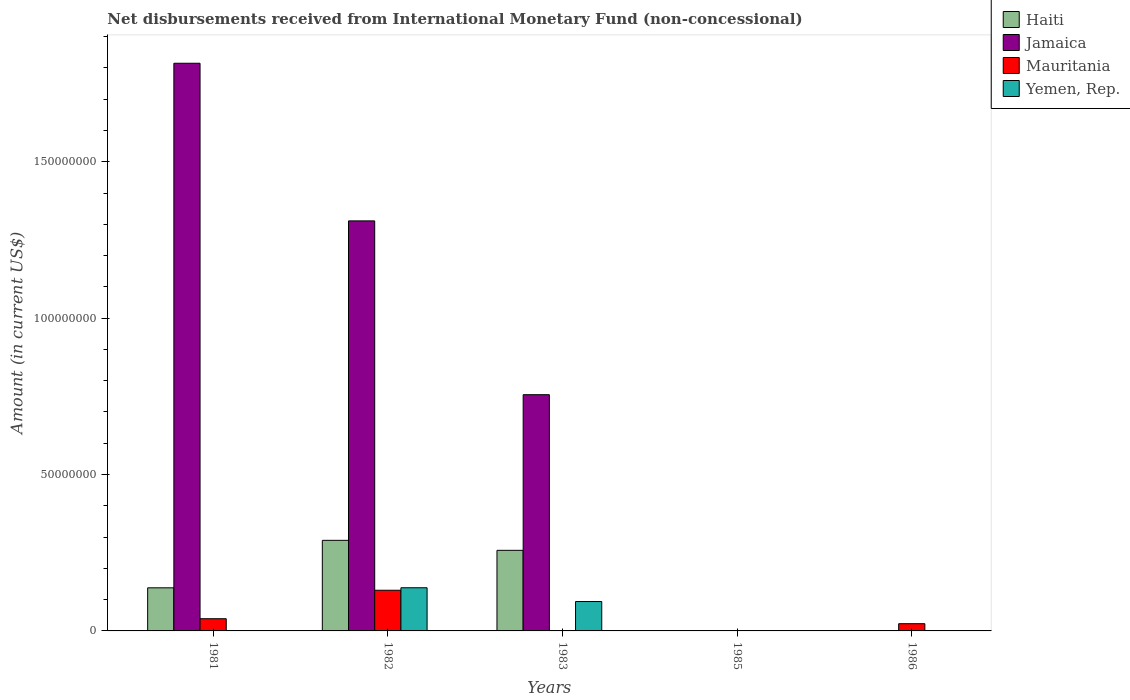How many different coloured bars are there?
Provide a succinct answer. 4. Are the number of bars per tick equal to the number of legend labels?
Offer a terse response. No. What is the label of the 4th group of bars from the left?
Your answer should be compact. 1985. In how many cases, is the number of bars for a given year not equal to the number of legend labels?
Your answer should be very brief. 4. Across all years, what is the maximum amount of disbursements received from International Monetary Fund in Yemen, Rep.?
Make the answer very short. 1.38e+07. Across all years, what is the minimum amount of disbursements received from International Monetary Fund in Jamaica?
Keep it short and to the point. 0. What is the total amount of disbursements received from International Monetary Fund in Jamaica in the graph?
Your answer should be compact. 3.88e+08. What is the difference between the amount of disbursements received from International Monetary Fund in Mauritania in 1982 and that in 1986?
Make the answer very short. 1.07e+07. What is the difference between the amount of disbursements received from International Monetary Fund in Jamaica in 1981 and the amount of disbursements received from International Monetary Fund in Mauritania in 1986?
Provide a short and direct response. 1.79e+08. What is the average amount of disbursements received from International Monetary Fund in Mauritania per year?
Your response must be concise. 3.84e+06. In the year 1981, what is the difference between the amount of disbursements received from International Monetary Fund in Jamaica and amount of disbursements received from International Monetary Fund in Haiti?
Your answer should be very brief. 1.68e+08. In how many years, is the amount of disbursements received from International Monetary Fund in Mauritania greater than 100000000 US$?
Offer a very short reply. 0. What is the ratio of the amount of disbursements received from International Monetary Fund in Haiti in 1981 to that in 1982?
Provide a succinct answer. 0.48. What is the difference between the highest and the second highest amount of disbursements received from International Monetary Fund in Mauritania?
Keep it short and to the point. 9.10e+06. What is the difference between the highest and the lowest amount of disbursements received from International Monetary Fund in Jamaica?
Your response must be concise. 1.82e+08. In how many years, is the amount of disbursements received from International Monetary Fund in Mauritania greater than the average amount of disbursements received from International Monetary Fund in Mauritania taken over all years?
Give a very brief answer. 2. Is the sum of the amount of disbursements received from International Monetary Fund in Mauritania in 1982 and 1986 greater than the maximum amount of disbursements received from International Monetary Fund in Jamaica across all years?
Your response must be concise. No. Is it the case that in every year, the sum of the amount of disbursements received from International Monetary Fund in Jamaica and amount of disbursements received from International Monetary Fund in Mauritania is greater than the sum of amount of disbursements received from International Monetary Fund in Haiti and amount of disbursements received from International Monetary Fund in Yemen, Rep.?
Offer a very short reply. No. What is the difference between two consecutive major ticks on the Y-axis?
Ensure brevity in your answer.  5.00e+07. How are the legend labels stacked?
Keep it short and to the point. Vertical. What is the title of the graph?
Keep it short and to the point. Net disbursements received from International Monetary Fund (non-concessional). What is the label or title of the X-axis?
Offer a very short reply. Years. What is the Amount (in current US$) in Haiti in 1981?
Provide a short and direct response. 1.38e+07. What is the Amount (in current US$) in Jamaica in 1981?
Provide a succinct answer. 1.82e+08. What is the Amount (in current US$) of Mauritania in 1981?
Your response must be concise. 3.90e+06. What is the Amount (in current US$) of Haiti in 1982?
Offer a very short reply. 2.90e+07. What is the Amount (in current US$) in Jamaica in 1982?
Your response must be concise. 1.31e+08. What is the Amount (in current US$) of Mauritania in 1982?
Your response must be concise. 1.30e+07. What is the Amount (in current US$) of Yemen, Rep. in 1982?
Offer a terse response. 1.38e+07. What is the Amount (in current US$) in Haiti in 1983?
Offer a terse response. 2.58e+07. What is the Amount (in current US$) of Jamaica in 1983?
Make the answer very short. 7.55e+07. What is the Amount (in current US$) in Yemen, Rep. in 1983?
Provide a short and direct response. 9.40e+06. What is the Amount (in current US$) in Jamaica in 1985?
Give a very brief answer. 0. What is the Amount (in current US$) of Mauritania in 1985?
Ensure brevity in your answer.  0. What is the Amount (in current US$) in Yemen, Rep. in 1985?
Keep it short and to the point. 0. What is the Amount (in current US$) of Mauritania in 1986?
Ensure brevity in your answer.  2.31e+06. What is the Amount (in current US$) in Yemen, Rep. in 1986?
Your answer should be compact. 0. Across all years, what is the maximum Amount (in current US$) of Haiti?
Ensure brevity in your answer.  2.90e+07. Across all years, what is the maximum Amount (in current US$) in Jamaica?
Your answer should be very brief. 1.82e+08. Across all years, what is the maximum Amount (in current US$) of Mauritania?
Offer a very short reply. 1.30e+07. Across all years, what is the maximum Amount (in current US$) in Yemen, Rep.?
Your answer should be very brief. 1.38e+07. Across all years, what is the minimum Amount (in current US$) in Yemen, Rep.?
Make the answer very short. 0. What is the total Amount (in current US$) in Haiti in the graph?
Give a very brief answer. 6.85e+07. What is the total Amount (in current US$) of Jamaica in the graph?
Make the answer very short. 3.88e+08. What is the total Amount (in current US$) of Mauritania in the graph?
Keep it short and to the point. 1.92e+07. What is the total Amount (in current US$) of Yemen, Rep. in the graph?
Your answer should be compact. 2.32e+07. What is the difference between the Amount (in current US$) in Haiti in 1981 and that in 1982?
Your response must be concise. -1.52e+07. What is the difference between the Amount (in current US$) in Jamaica in 1981 and that in 1982?
Provide a short and direct response. 5.04e+07. What is the difference between the Amount (in current US$) of Mauritania in 1981 and that in 1982?
Your answer should be very brief. -9.10e+06. What is the difference between the Amount (in current US$) of Haiti in 1981 and that in 1983?
Provide a short and direct response. -1.20e+07. What is the difference between the Amount (in current US$) of Jamaica in 1981 and that in 1983?
Your answer should be compact. 1.06e+08. What is the difference between the Amount (in current US$) in Mauritania in 1981 and that in 1986?
Ensure brevity in your answer.  1.59e+06. What is the difference between the Amount (in current US$) in Haiti in 1982 and that in 1983?
Ensure brevity in your answer.  3.20e+06. What is the difference between the Amount (in current US$) in Jamaica in 1982 and that in 1983?
Your answer should be compact. 5.56e+07. What is the difference between the Amount (in current US$) in Yemen, Rep. in 1982 and that in 1983?
Offer a very short reply. 4.40e+06. What is the difference between the Amount (in current US$) of Mauritania in 1982 and that in 1986?
Give a very brief answer. 1.07e+07. What is the difference between the Amount (in current US$) of Haiti in 1981 and the Amount (in current US$) of Jamaica in 1982?
Your answer should be very brief. -1.17e+08. What is the difference between the Amount (in current US$) of Haiti in 1981 and the Amount (in current US$) of Mauritania in 1982?
Offer a very short reply. 7.81e+05. What is the difference between the Amount (in current US$) in Haiti in 1981 and the Amount (in current US$) in Yemen, Rep. in 1982?
Your answer should be very brief. -1.90e+04. What is the difference between the Amount (in current US$) of Jamaica in 1981 and the Amount (in current US$) of Mauritania in 1982?
Your response must be concise. 1.68e+08. What is the difference between the Amount (in current US$) in Jamaica in 1981 and the Amount (in current US$) in Yemen, Rep. in 1982?
Offer a terse response. 1.68e+08. What is the difference between the Amount (in current US$) in Mauritania in 1981 and the Amount (in current US$) in Yemen, Rep. in 1982?
Give a very brief answer. -9.90e+06. What is the difference between the Amount (in current US$) of Haiti in 1981 and the Amount (in current US$) of Jamaica in 1983?
Your response must be concise. -6.17e+07. What is the difference between the Amount (in current US$) of Haiti in 1981 and the Amount (in current US$) of Yemen, Rep. in 1983?
Your response must be concise. 4.38e+06. What is the difference between the Amount (in current US$) in Jamaica in 1981 and the Amount (in current US$) in Yemen, Rep. in 1983?
Offer a very short reply. 1.72e+08. What is the difference between the Amount (in current US$) of Mauritania in 1981 and the Amount (in current US$) of Yemen, Rep. in 1983?
Offer a terse response. -5.50e+06. What is the difference between the Amount (in current US$) of Haiti in 1981 and the Amount (in current US$) of Mauritania in 1986?
Your response must be concise. 1.15e+07. What is the difference between the Amount (in current US$) of Jamaica in 1981 and the Amount (in current US$) of Mauritania in 1986?
Ensure brevity in your answer.  1.79e+08. What is the difference between the Amount (in current US$) of Haiti in 1982 and the Amount (in current US$) of Jamaica in 1983?
Your answer should be compact. -4.66e+07. What is the difference between the Amount (in current US$) in Haiti in 1982 and the Amount (in current US$) in Yemen, Rep. in 1983?
Give a very brief answer. 1.96e+07. What is the difference between the Amount (in current US$) of Jamaica in 1982 and the Amount (in current US$) of Yemen, Rep. in 1983?
Offer a very short reply. 1.22e+08. What is the difference between the Amount (in current US$) of Mauritania in 1982 and the Amount (in current US$) of Yemen, Rep. in 1983?
Ensure brevity in your answer.  3.60e+06. What is the difference between the Amount (in current US$) of Haiti in 1982 and the Amount (in current US$) of Mauritania in 1986?
Give a very brief answer. 2.67e+07. What is the difference between the Amount (in current US$) in Jamaica in 1982 and the Amount (in current US$) in Mauritania in 1986?
Provide a short and direct response. 1.29e+08. What is the difference between the Amount (in current US$) of Haiti in 1983 and the Amount (in current US$) of Mauritania in 1986?
Keep it short and to the point. 2.35e+07. What is the difference between the Amount (in current US$) in Jamaica in 1983 and the Amount (in current US$) in Mauritania in 1986?
Offer a terse response. 7.32e+07. What is the average Amount (in current US$) of Haiti per year?
Offer a terse response. 1.37e+07. What is the average Amount (in current US$) in Jamaica per year?
Ensure brevity in your answer.  7.76e+07. What is the average Amount (in current US$) of Mauritania per year?
Ensure brevity in your answer.  3.84e+06. What is the average Amount (in current US$) in Yemen, Rep. per year?
Give a very brief answer. 4.64e+06. In the year 1981, what is the difference between the Amount (in current US$) of Haiti and Amount (in current US$) of Jamaica?
Your response must be concise. -1.68e+08. In the year 1981, what is the difference between the Amount (in current US$) in Haiti and Amount (in current US$) in Mauritania?
Ensure brevity in your answer.  9.88e+06. In the year 1981, what is the difference between the Amount (in current US$) in Jamaica and Amount (in current US$) in Mauritania?
Keep it short and to the point. 1.78e+08. In the year 1982, what is the difference between the Amount (in current US$) of Haiti and Amount (in current US$) of Jamaica?
Your response must be concise. -1.02e+08. In the year 1982, what is the difference between the Amount (in current US$) in Haiti and Amount (in current US$) in Mauritania?
Give a very brief answer. 1.60e+07. In the year 1982, what is the difference between the Amount (in current US$) in Haiti and Amount (in current US$) in Yemen, Rep.?
Offer a very short reply. 1.52e+07. In the year 1982, what is the difference between the Amount (in current US$) of Jamaica and Amount (in current US$) of Mauritania?
Your response must be concise. 1.18e+08. In the year 1982, what is the difference between the Amount (in current US$) of Jamaica and Amount (in current US$) of Yemen, Rep.?
Your answer should be compact. 1.17e+08. In the year 1982, what is the difference between the Amount (in current US$) of Mauritania and Amount (in current US$) of Yemen, Rep.?
Keep it short and to the point. -8.00e+05. In the year 1983, what is the difference between the Amount (in current US$) in Haiti and Amount (in current US$) in Jamaica?
Your answer should be compact. -4.98e+07. In the year 1983, what is the difference between the Amount (in current US$) of Haiti and Amount (in current US$) of Yemen, Rep.?
Your response must be concise. 1.64e+07. In the year 1983, what is the difference between the Amount (in current US$) in Jamaica and Amount (in current US$) in Yemen, Rep.?
Offer a terse response. 6.61e+07. What is the ratio of the Amount (in current US$) in Haiti in 1981 to that in 1982?
Provide a succinct answer. 0.48. What is the ratio of the Amount (in current US$) in Jamaica in 1981 to that in 1982?
Your answer should be very brief. 1.38. What is the ratio of the Amount (in current US$) in Mauritania in 1981 to that in 1982?
Offer a terse response. 0.3. What is the ratio of the Amount (in current US$) in Haiti in 1981 to that in 1983?
Your answer should be very brief. 0.53. What is the ratio of the Amount (in current US$) in Jamaica in 1981 to that in 1983?
Make the answer very short. 2.4. What is the ratio of the Amount (in current US$) in Mauritania in 1981 to that in 1986?
Make the answer very short. 1.69. What is the ratio of the Amount (in current US$) in Haiti in 1982 to that in 1983?
Give a very brief answer. 1.12. What is the ratio of the Amount (in current US$) of Jamaica in 1982 to that in 1983?
Offer a very short reply. 1.74. What is the ratio of the Amount (in current US$) in Yemen, Rep. in 1982 to that in 1983?
Provide a short and direct response. 1.47. What is the ratio of the Amount (in current US$) in Mauritania in 1982 to that in 1986?
Keep it short and to the point. 5.63. What is the difference between the highest and the second highest Amount (in current US$) in Haiti?
Give a very brief answer. 3.20e+06. What is the difference between the highest and the second highest Amount (in current US$) in Jamaica?
Your answer should be compact. 5.04e+07. What is the difference between the highest and the second highest Amount (in current US$) of Mauritania?
Offer a very short reply. 9.10e+06. What is the difference between the highest and the lowest Amount (in current US$) of Haiti?
Your response must be concise. 2.90e+07. What is the difference between the highest and the lowest Amount (in current US$) of Jamaica?
Provide a short and direct response. 1.82e+08. What is the difference between the highest and the lowest Amount (in current US$) of Mauritania?
Your answer should be compact. 1.30e+07. What is the difference between the highest and the lowest Amount (in current US$) of Yemen, Rep.?
Keep it short and to the point. 1.38e+07. 